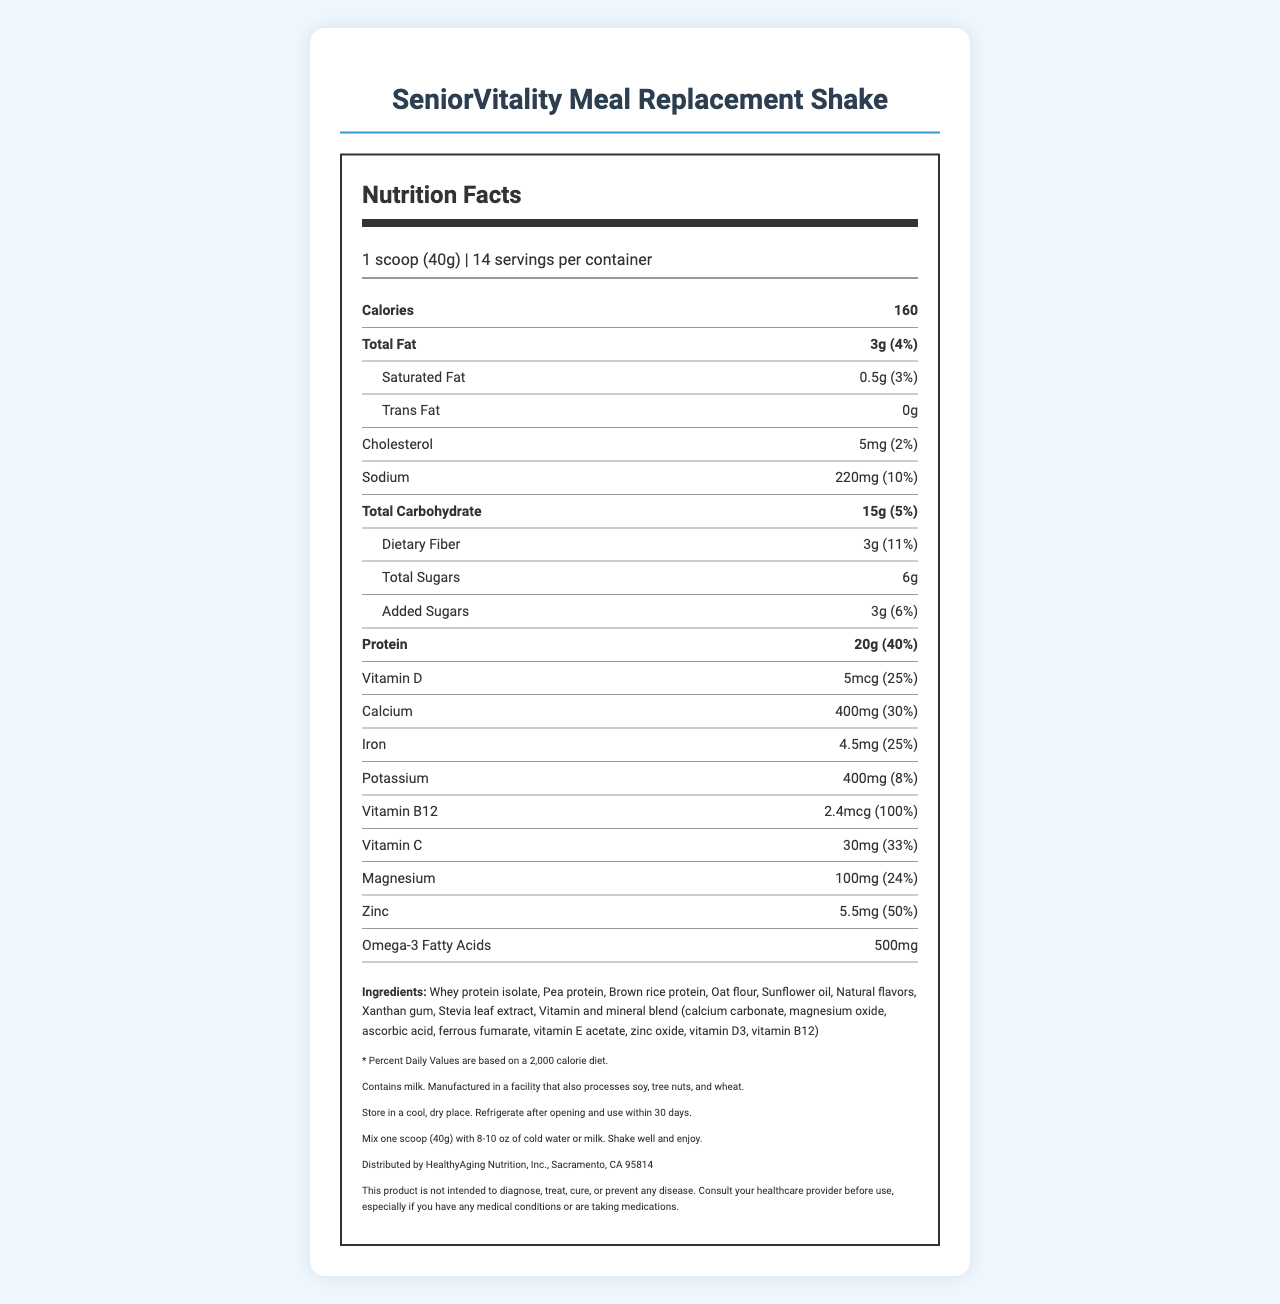what is the serving size of the SeniorVitality Meal Replacement Shake? The serving size is mentioned at the top of the nutrition label as "1 scoop (40g)".
Answer: 1 scoop (40g) how many calories are there per serving? The number of calories per serving is listed as "Calories 160" on the nutrition label.
Answer: 160 how much protein is in one serving? The protein content is specified under the protein section as "Protein 20g".
Answer: 20g what are the main sources of protein in this meal replacement shake? These ingredients are listed in the ingredients section as sources of protein.
Answer: Whey protein isolate, Pea protein, Brown rice protein how many servings are there in one container of SeniorVitality Meal Replacement Shake? The number of servings per container is shown in the serving information as "14 servings per container".
Answer: 14 which of the following nutrients contribute to 100% of the daily value per serving? 
A. Vitamin D 
B. Vitamin B12 
C. Zinc 
D. Calcium Vitamin B12 contributes to 100% of the daily value per serving as indicated in the nutrition information.
Answer: B based on the nutrition facts label, what percentage of the daily value of saturated fat is provided by one serving? 
1. 2%
2. 3%
3. 4%
4. 5% The percentage daily value of saturated fat is given as "3%" on the nutrition label.
Answer: 2 is the meal replacement shake high in sodium? One serving contains 220mg of sodium which is 10% of the daily value, indicating a relatively high sodium content.
Answer: Yes are there any trans fats in the SeniorVitality Meal Replacement Shake? The trans fat content is listed as "0g".
Answer: No does the product contain any allergens? The allergen information indicates that the product contains milk and is manufactured in a facility that processes soy, tree nuts, and wheat.
Answer: Yes provide a summary of the document The summary provides an overview of the key nutritional information, ingredients, and instructions found in the document.
Answer: The document details the nutrition facts for the SeniorVitality Meal Replacement Shake, including serving size (1 scoop or 40g), calories per serving (160), protein content (20g), and essential nutrients such as Vitamin B12, Vitamin D, and Zinc among others. It also lists the ingredients, allergen information, storage, and preparation instructions. The product contains 14 servings per container. what is the exact amount of omega-3 fatty acids in one serving? The amount of omega-3 fatty acids per serving is mentioned as "500mg" under the nutrient information.
Answer: 500mg how much total carbohydrate does one serving contain? The total carbohydrate content is listed as "15g" on the nutrition label.
Answer: 15g can the exact manufacturing location be determined from the document? The document only provides the distribution information by HealthyAging Nutrition, Inc., but does not specify the exact manufacturing location.
Answer: No what is the percentage daily value of dietary fiber per serving? The percentage daily value of dietary fiber per serving is listed as "11%".
Answer: 11% which nutrient has the highest daily value percentage in this meal replacement shake? The nutrition label shows that Vitamin B12 has the highest daily value percentage of 100%.
Answer: Vitamin B12 